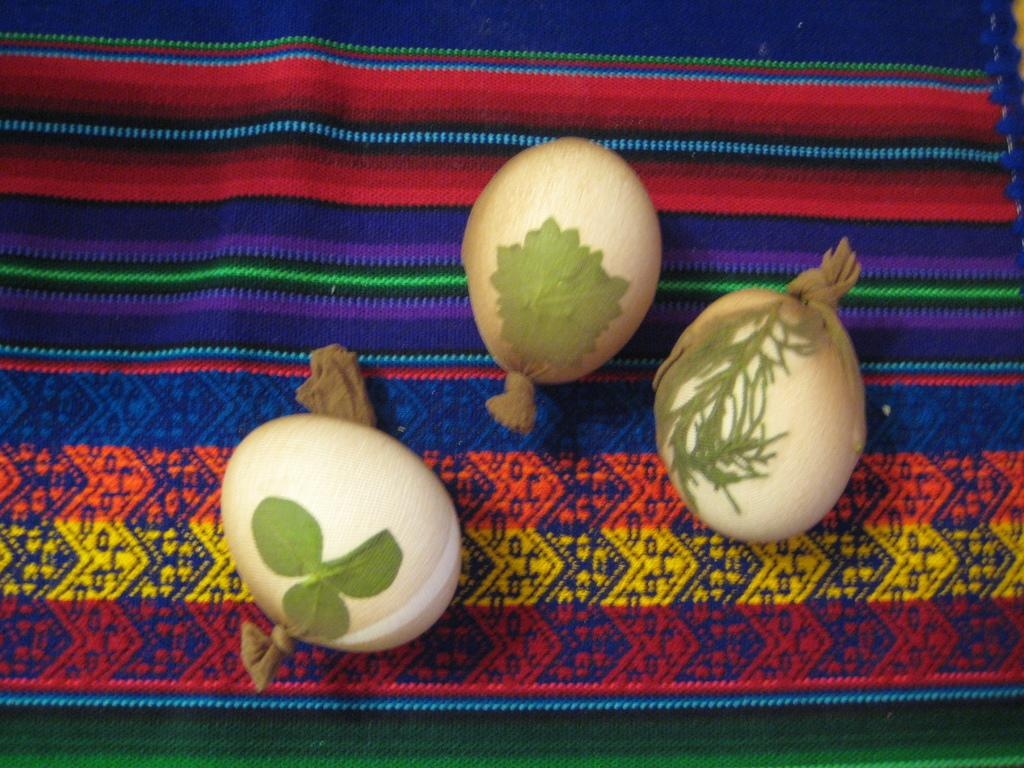What is the primary surface on which the objects are placed in the image? There are objects on a mat in the image. Can you describe the objects on the mat? Unfortunately, the provided facts do not specify the nature of the objects on the mat. What might be the purpose of the mat in the image? The purpose of the mat in the image is not clear from the given facts. How many bombs are visible on the mat in the image? There is no mention of bombs in the image, as the facts only state that there are objects on a mat. 